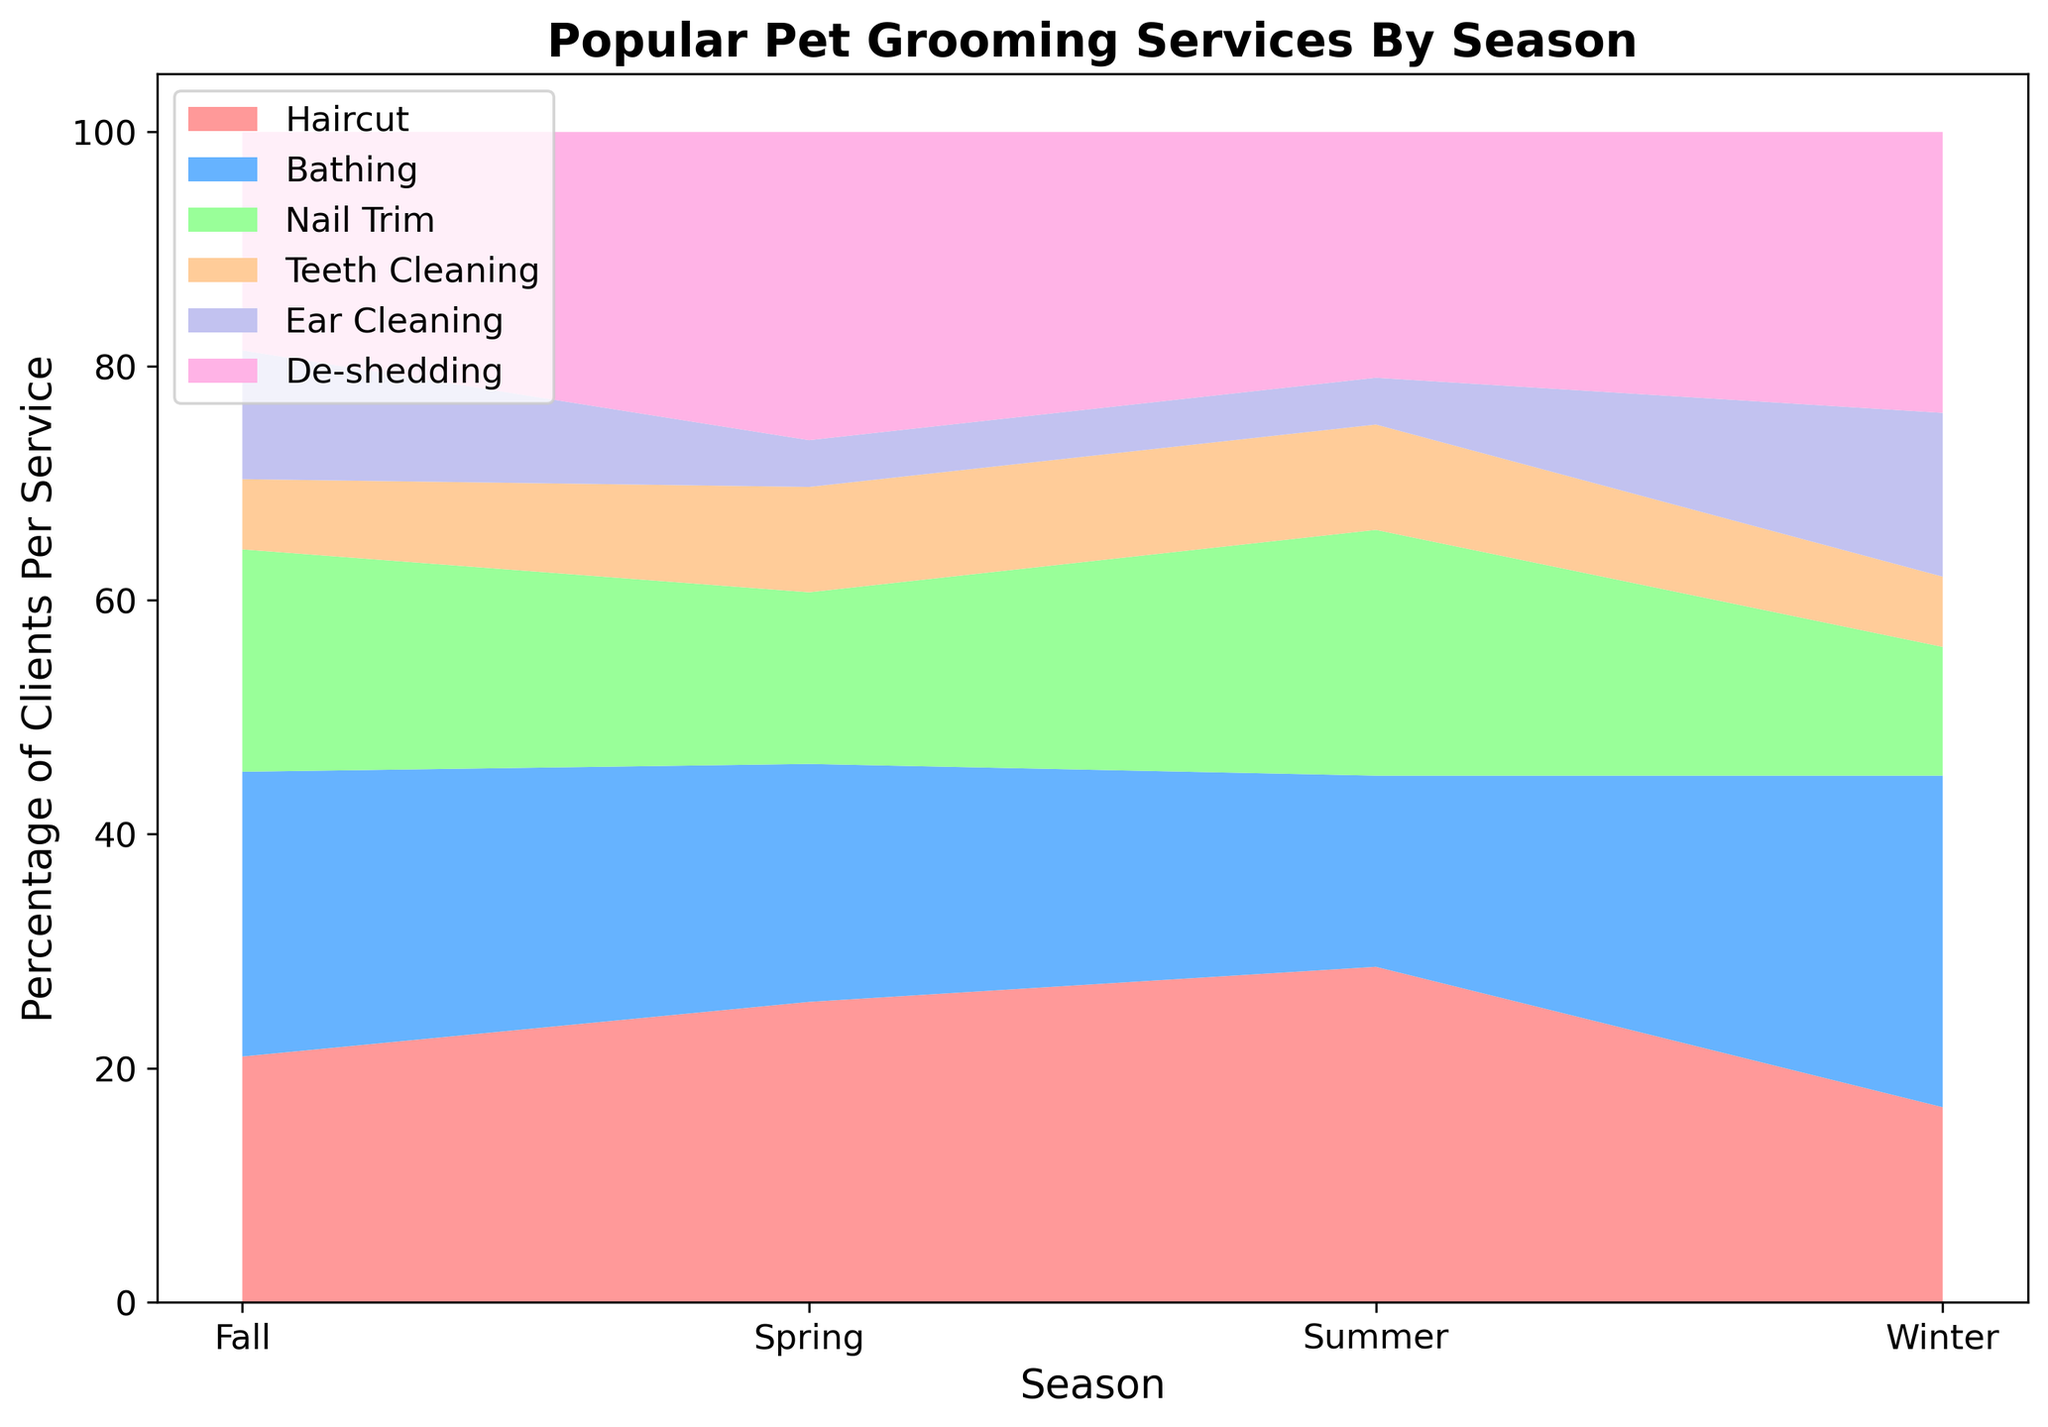Which season has the highest percentage for Bathing services? Look at the area chart and identify the segment representing Bathing (blue color). Check which season has the largest area for Bathing.
Answer: Winter Which grooming service shows the largest percentage change between Spring and Fall? Find the difference in the heights of each service segment for Spring and Fall. Compare the differences to find the largest change.
Answer: Bathing What is the combined percentage of Nail Trim and Ear Cleaning services in Summer? For Summer, identify the segments for Nail Trim (green) and Ear Cleaning (purple) and add their heights together.
Answer: 25% Is the De-shedding service more popular in Spring or Winter? Compare the height of the De-shedding (pink) segment for Spring and Winter.
Answer: Spring Which season has the lowest percentage for Teeth Cleaning services? Identify the Teeth Cleaning (orange) segment in the chart and find the season with the smallest height.
Answer: Spring Are Bathing services more popular in Fall compared to Spring? Compare the heights of the Bathing (blue) segments in Fall and Spring.
Answer: Yes Between Nail Trim and De-shedding, which service is more popular in Winter? Compare the heights of the Nail Trim (green) and De-shedding (pink) segments in Winter.
Answer: De-shedding During which season is the percentage of Haircut services at its peak? Identify the Haircut (red) segment in the chart and find the season where it reaches its highest point.
Answer: Summer What is the average percentage of Bathing services across all seasons? Sum the percentage values for Bathing across all seasons (i.e., Spring, Summer, Fall, Winter) and divide by the number of seasons.
Answer: 23.25% Which two services are the most popular in Summer? Identify the two segments with the greatest heights in Summer. Compare the heights to determine the top two services.
Answer: Haircut, Nail Trim 